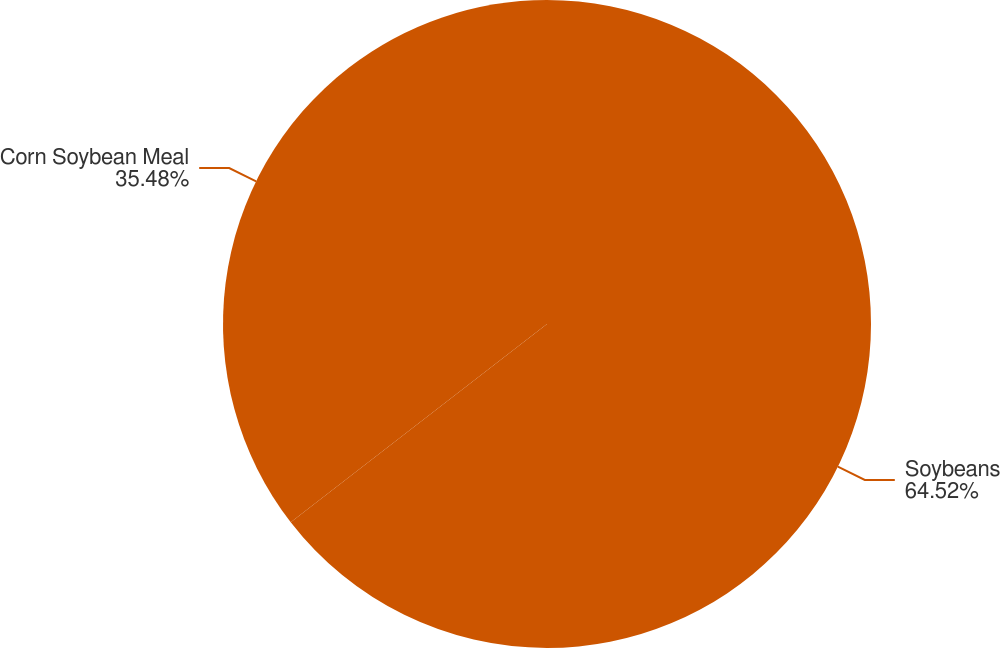Convert chart to OTSL. <chart><loc_0><loc_0><loc_500><loc_500><pie_chart><fcel>Soybeans<fcel>Corn Soybean Meal<nl><fcel>64.52%<fcel>35.48%<nl></chart> 